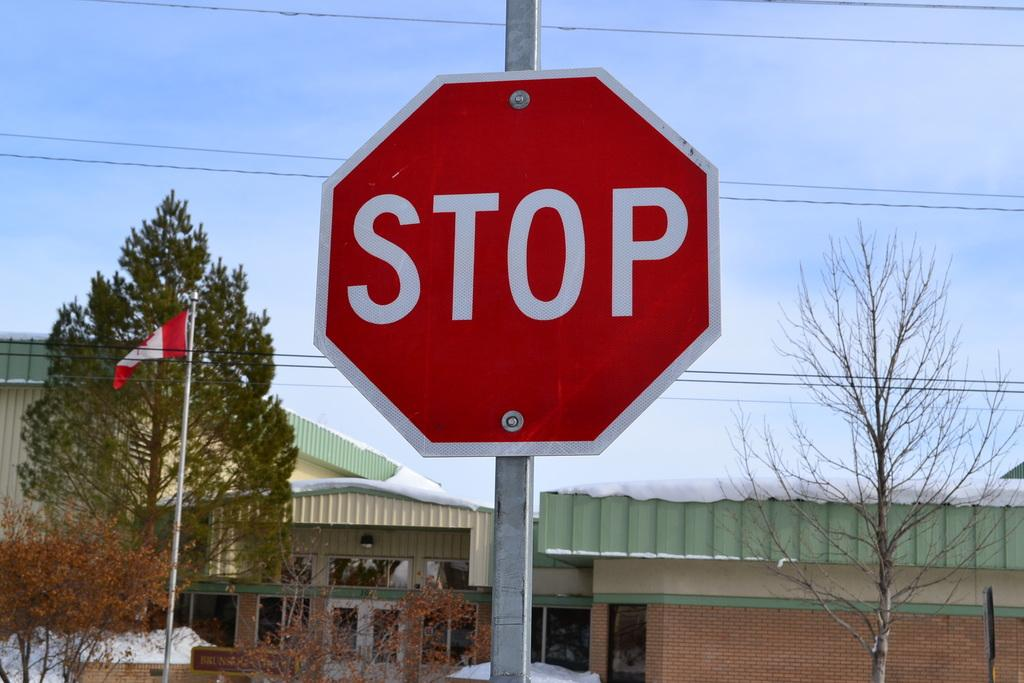<image>
Share a concise interpretation of the image provided. A red stop sign is mounted to a metal post. 